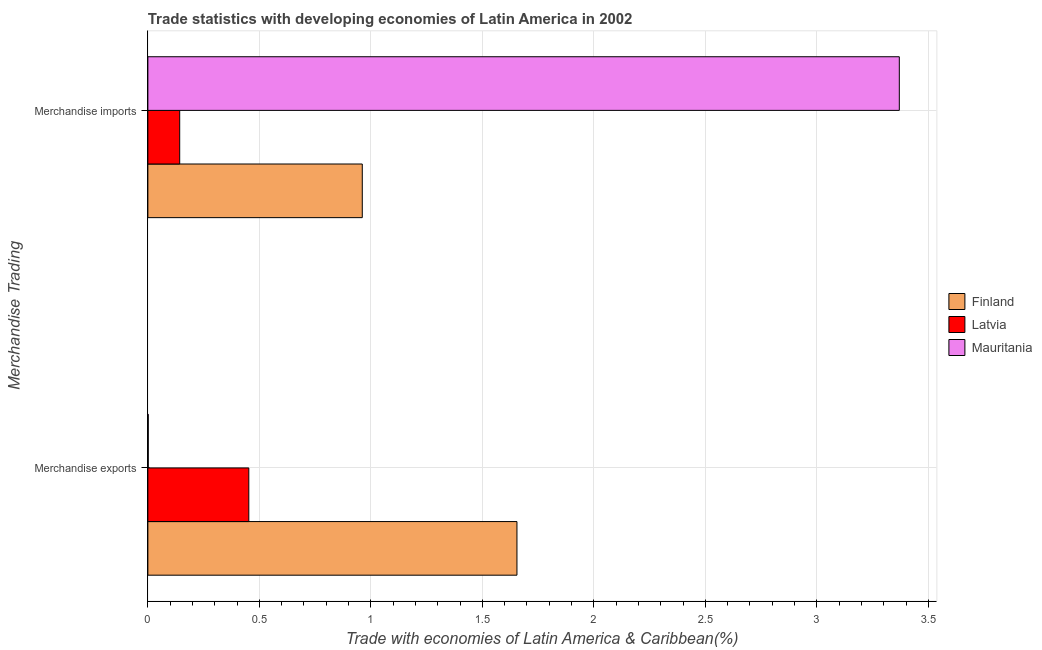Are the number of bars on each tick of the Y-axis equal?
Offer a very short reply. Yes. How many bars are there on the 1st tick from the bottom?
Your response must be concise. 3. What is the merchandise exports in Finland?
Give a very brief answer. 1.66. Across all countries, what is the maximum merchandise imports?
Ensure brevity in your answer.  3.37. Across all countries, what is the minimum merchandise imports?
Offer a terse response. 0.14. In which country was the merchandise imports maximum?
Make the answer very short. Mauritania. In which country was the merchandise imports minimum?
Offer a terse response. Latvia. What is the total merchandise exports in the graph?
Provide a succinct answer. 2.11. What is the difference between the merchandise exports in Mauritania and that in Latvia?
Your answer should be compact. -0.45. What is the difference between the merchandise imports in Latvia and the merchandise exports in Mauritania?
Offer a very short reply. 0.14. What is the average merchandise imports per country?
Your response must be concise. 1.49. What is the difference between the merchandise exports and merchandise imports in Mauritania?
Your response must be concise. -3.37. What is the ratio of the merchandise imports in Latvia to that in Mauritania?
Your response must be concise. 0.04. Is the merchandise imports in Latvia less than that in Mauritania?
Your response must be concise. Yes. In how many countries, is the merchandise exports greater than the average merchandise exports taken over all countries?
Provide a short and direct response. 1. What does the 1st bar from the top in Merchandise imports represents?
Provide a succinct answer. Mauritania. How many countries are there in the graph?
Ensure brevity in your answer.  3. What is the difference between two consecutive major ticks on the X-axis?
Your answer should be very brief. 0.5. Are the values on the major ticks of X-axis written in scientific E-notation?
Your answer should be very brief. No. Does the graph contain any zero values?
Your answer should be very brief. No. Where does the legend appear in the graph?
Your response must be concise. Center right. How are the legend labels stacked?
Offer a very short reply. Vertical. What is the title of the graph?
Give a very brief answer. Trade statistics with developing economies of Latin America in 2002. What is the label or title of the X-axis?
Offer a very short reply. Trade with economies of Latin America & Caribbean(%). What is the label or title of the Y-axis?
Ensure brevity in your answer.  Merchandise Trading. What is the Trade with economies of Latin America & Caribbean(%) in Finland in Merchandise exports?
Your response must be concise. 1.66. What is the Trade with economies of Latin America & Caribbean(%) in Latvia in Merchandise exports?
Offer a terse response. 0.45. What is the Trade with economies of Latin America & Caribbean(%) of Mauritania in Merchandise exports?
Give a very brief answer. 0. What is the Trade with economies of Latin America & Caribbean(%) in Finland in Merchandise imports?
Keep it short and to the point. 0.96. What is the Trade with economies of Latin America & Caribbean(%) of Latvia in Merchandise imports?
Ensure brevity in your answer.  0.14. What is the Trade with economies of Latin America & Caribbean(%) in Mauritania in Merchandise imports?
Your answer should be compact. 3.37. Across all Merchandise Trading, what is the maximum Trade with economies of Latin America & Caribbean(%) of Finland?
Provide a short and direct response. 1.66. Across all Merchandise Trading, what is the maximum Trade with economies of Latin America & Caribbean(%) in Latvia?
Your answer should be very brief. 0.45. Across all Merchandise Trading, what is the maximum Trade with economies of Latin America & Caribbean(%) of Mauritania?
Your response must be concise. 3.37. Across all Merchandise Trading, what is the minimum Trade with economies of Latin America & Caribbean(%) in Finland?
Your answer should be very brief. 0.96. Across all Merchandise Trading, what is the minimum Trade with economies of Latin America & Caribbean(%) of Latvia?
Your answer should be very brief. 0.14. Across all Merchandise Trading, what is the minimum Trade with economies of Latin America & Caribbean(%) of Mauritania?
Your response must be concise. 0. What is the total Trade with economies of Latin America & Caribbean(%) of Finland in the graph?
Keep it short and to the point. 2.62. What is the total Trade with economies of Latin America & Caribbean(%) in Latvia in the graph?
Ensure brevity in your answer.  0.6. What is the total Trade with economies of Latin America & Caribbean(%) in Mauritania in the graph?
Your answer should be very brief. 3.37. What is the difference between the Trade with economies of Latin America & Caribbean(%) of Finland in Merchandise exports and that in Merchandise imports?
Provide a short and direct response. 0.69. What is the difference between the Trade with economies of Latin America & Caribbean(%) in Latvia in Merchandise exports and that in Merchandise imports?
Give a very brief answer. 0.31. What is the difference between the Trade with economies of Latin America & Caribbean(%) of Mauritania in Merchandise exports and that in Merchandise imports?
Offer a terse response. -3.37. What is the difference between the Trade with economies of Latin America & Caribbean(%) in Finland in Merchandise exports and the Trade with economies of Latin America & Caribbean(%) in Latvia in Merchandise imports?
Your answer should be compact. 1.51. What is the difference between the Trade with economies of Latin America & Caribbean(%) of Finland in Merchandise exports and the Trade with economies of Latin America & Caribbean(%) of Mauritania in Merchandise imports?
Provide a succinct answer. -1.71. What is the difference between the Trade with economies of Latin America & Caribbean(%) in Latvia in Merchandise exports and the Trade with economies of Latin America & Caribbean(%) in Mauritania in Merchandise imports?
Your response must be concise. -2.92. What is the average Trade with economies of Latin America & Caribbean(%) in Finland per Merchandise Trading?
Offer a terse response. 1.31. What is the average Trade with economies of Latin America & Caribbean(%) in Latvia per Merchandise Trading?
Make the answer very short. 0.3. What is the average Trade with economies of Latin America & Caribbean(%) in Mauritania per Merchandise Trading?
Your answer should be compact. 1.69. What is the difference between the Trade with economies of Latin America & Caribbean(%) in Finland and Trade with economies of Latin America & Caribbean(%) in Latvia in Merchandise exports?
Your answer should be very brief. 1.2. What is the difference between the Trade with economies of Latin America & Caribbean(%) of Finland and Trade with economies of Latin America & Caribbean(%) of Mauritania in Merchandise exports?
Provide a short and direct response. 1.65. What is the difference between the Trade with economies of Latin America & Caribbean(%) in Latvia and Trade with economies of Latin America & Caribbean(%) in Mauritania in Merchandise exports?
Provide a short and direct response. 0.45. What is the difference between the Trade with economies of Latin America & Caribbean(%) in Finland and Trade with economies of Latin America & Caribbean(%) in Latvia in Merchandise imports?
Your answer should be very brief. 0.82. What is the difference between the Trade with economies of Latin America & Caribbean(%) in Finland and Trade with economies of Latin America & Caribbean(%) in Mauritania in Merchandise imports?
Keep it short and to the point. -2.41. What is the difference between the Trade with economies of Latin America & Caribbean(%) in Latvia and Trade with economies of Latin America & Caribbean(%) in Mauritania in Merchandise imports?
Give a very brief answer. -3.23. What is the ratio of the Trade with economies of Latin America & Caribbean(%) in Finland in Merchandise exports to that in Merchandise imports?
Offer a very short reply. 1.72. What is the ratio of the Trade with economies of Latin America & Caribbean(%) of Latvia in Merchandise exports to that in Merchandise imports?
Your answer should be very brief. 3.17. What is the ratio of the Trade with economies of Latin America & Caribbean(%) of Mauritania in Merchandise exports to that in Merchandise imports?
Your answer should be compact. 0. What is the difference between the highest and the second highest Trade with economies of Latin America & Caribbean(%) of Finland?
Your response must be concise. 0.69. What is the difference between the highest and the second highest Trade with economies of Latin America & Caribbean(%) of Latvia?
Ensure brevity in your answer.  0.31. What is the difference between the highest and the second highest Trade with economies of Latin America & Caribbean(%) in Mauritania?
Provide a succinct answer. 3.37. What is the difference between the highest and the lowest Trade with economies of Latin America & Caribbean(%) in Finland?
Offer a very short reply. 0.69. What is the difference between the highest and the lowest Trade with economies of Latin America & Caribbean(%) in Latvia?
Make the answer very short. 0.31. What is the difference between the highest and the lowest Trade with economies of Latin America & Caribbean(%) in Mauritania?
Make the answer very short. 3.37. 